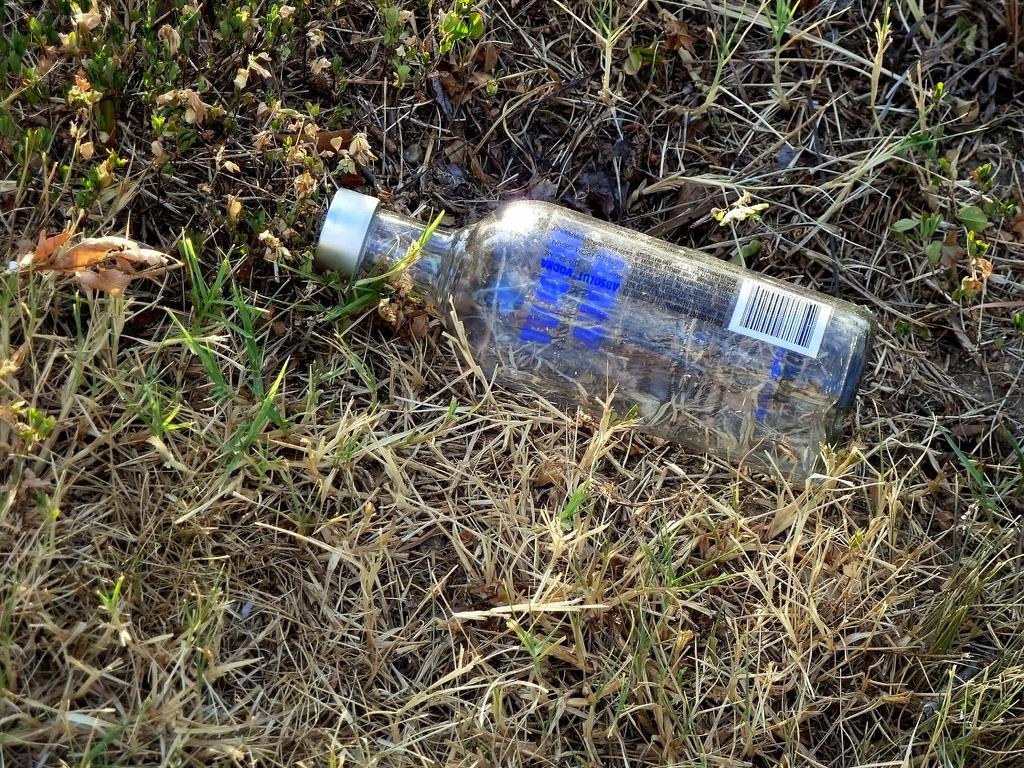Could you give a brief overview of what you see in this image? In this image I can see a bottle on the grass. 